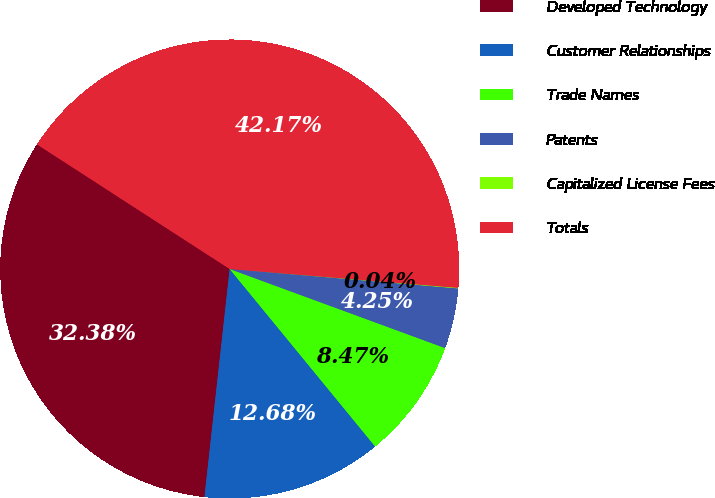Convert chart. <chart><loc_0><loc_0><loc_500><loc_500><pie_chart><fcel>Developed Technology<fcel>Customer Relationships<fcel>Trade Names<fcel>Patents<fcel>Capitalized License Fees<fcel>Totals<nl><fcel>32.38%<fcel>12.68%<fcel>8.47%<fcel>4.25%<fcel>0.04%<fcel>42.17%<nl></chart> 